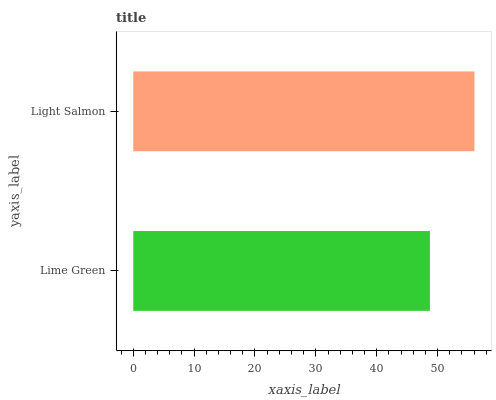Is Lime Green the minimum?
Answer yes or no. Yes. Is Light Salmon the maximum?
Answer yes or no. Yes. Is Light Salmon the minimum?
Answer yes or no. No. Is Light Salmon greater than Lime Green?
Answer yes or no. Yes. Is Lime Green less than Light Salmon?
Answer yes or no. Yes. Is Lime Green greater than Light Salmon?
Answer yes or no. No. Is Light Salmon less than Lime Green?
Answer yes or no. No. Is Light Salmon the high median?
Answer yes or no. Yes. Is Lime Green the low median?
Answer yes or no. Yes. Is Lime Green the high median?
Answer yes or no. No. Is Light Salmon the low median?
Answer yes or no. No. 